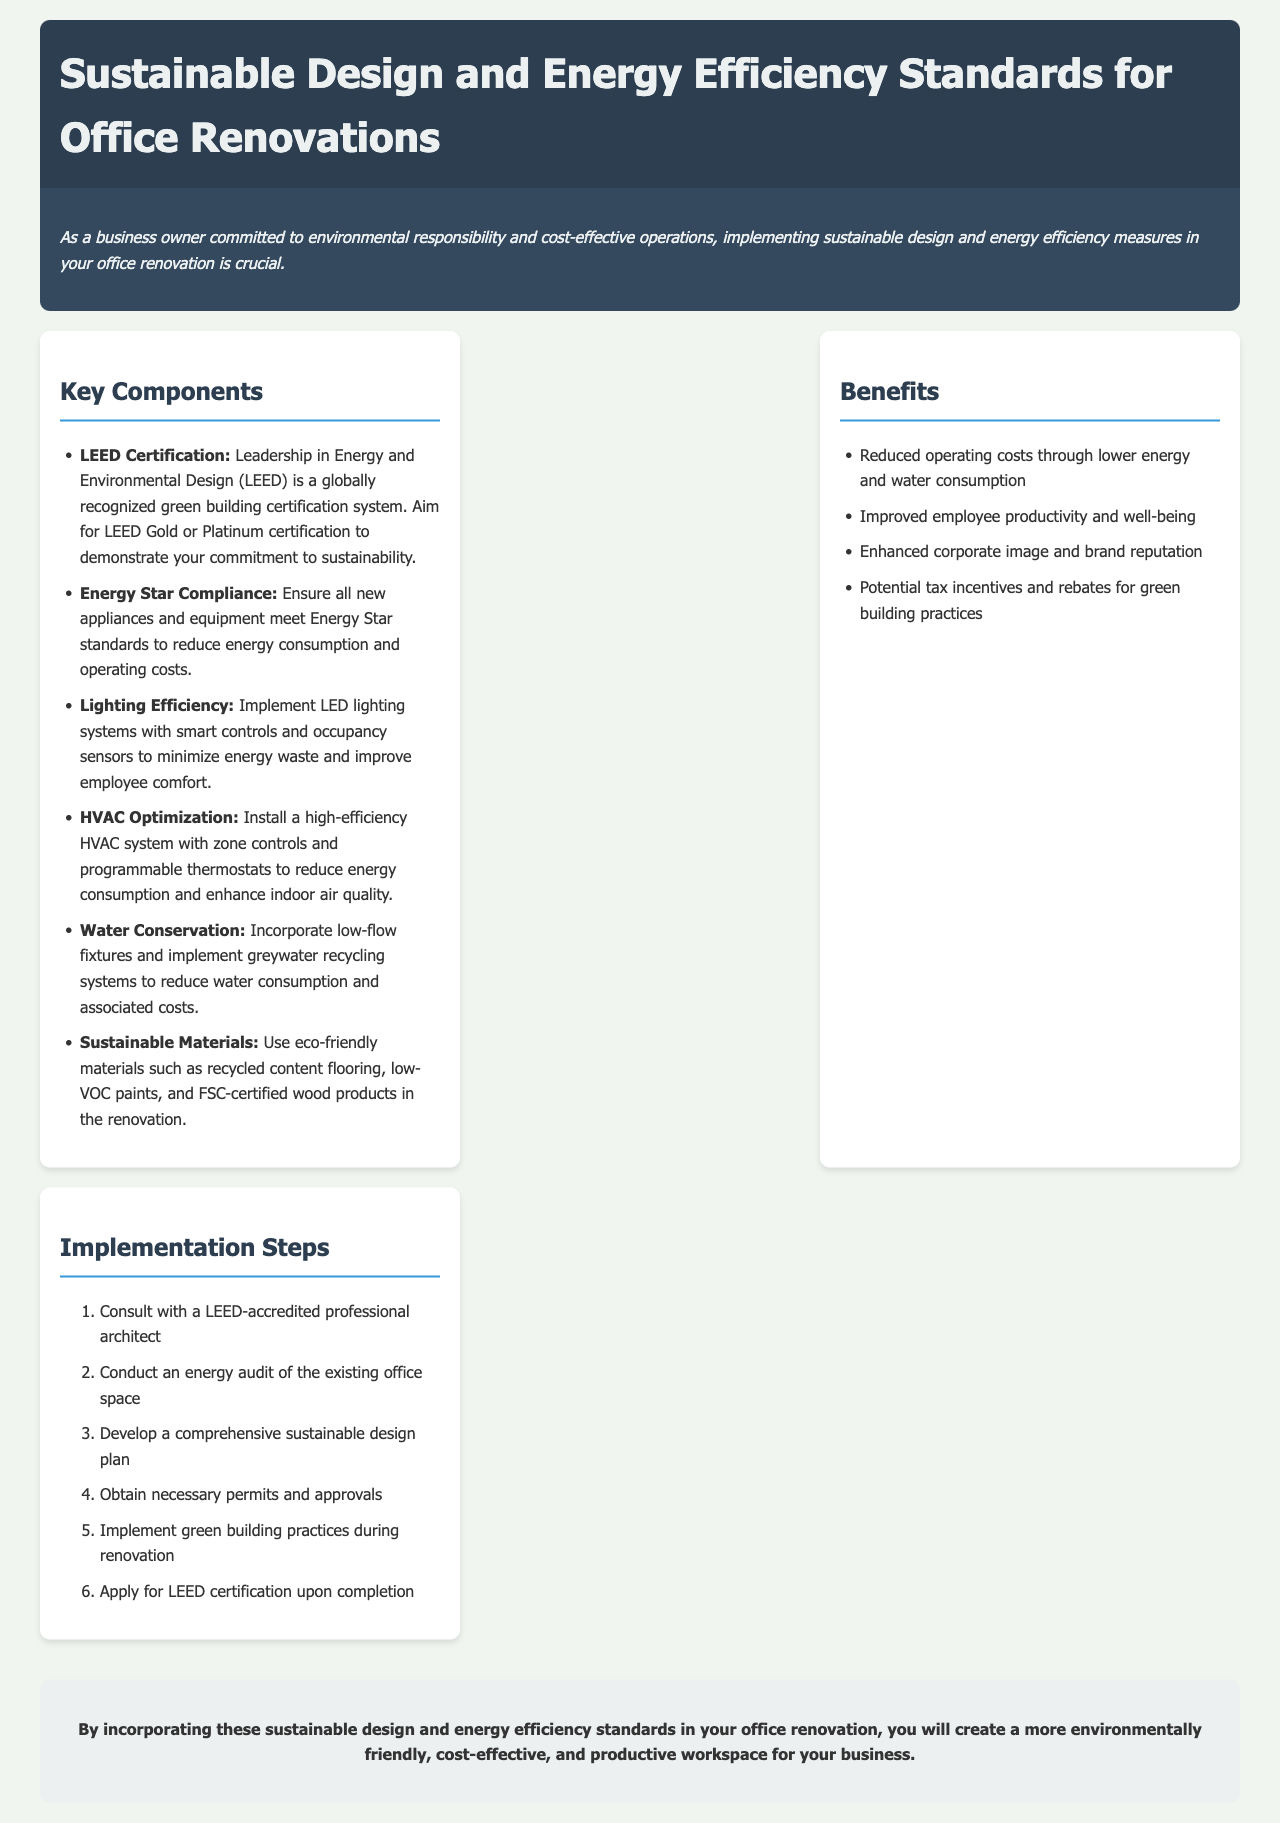What is LEED? LEED stands for Leadership in Energy and Environmental Design, a globally recognized green building certification system.
Answer: Leadership in Energy and Environmental Design What is the goal for LEED certification in renovations? Aim for LEED Gold or Platinum certification to demonstrate commitment to sustainability.
Answer: Gold or Platinum Which lighting system is recommended? Implement LED lighting systems with smart controls and occupancy sensors.
Answer: LED lighting systems What is one benefit of sustainable design? Reduced operating costs through lower energy and water consumption.
Answer: Reduced operating costs What is the first step in the implementation process? Consult with a LEED-accredited professional architect.
Answer: Consult with a LEED-accredited professional architect How many key components are listed in the document? There are six key components mentioned in the document.
Answer: Six What type of fixtures should be incorporated for water conservation? Incorporate low-flow fixtures.
Answer: Low-flow fixtures What does HVAC stand for? HVAC stands for Heating, Ventilation, and Air Conditioning.
Answer: Heating, Ventilation, and Air Conditioning What do Energy Star appliances aim to reduce? Energy Star appliances aim to reduce energy consumption and operating costs.
Answer: Energy consumption and operating costs 